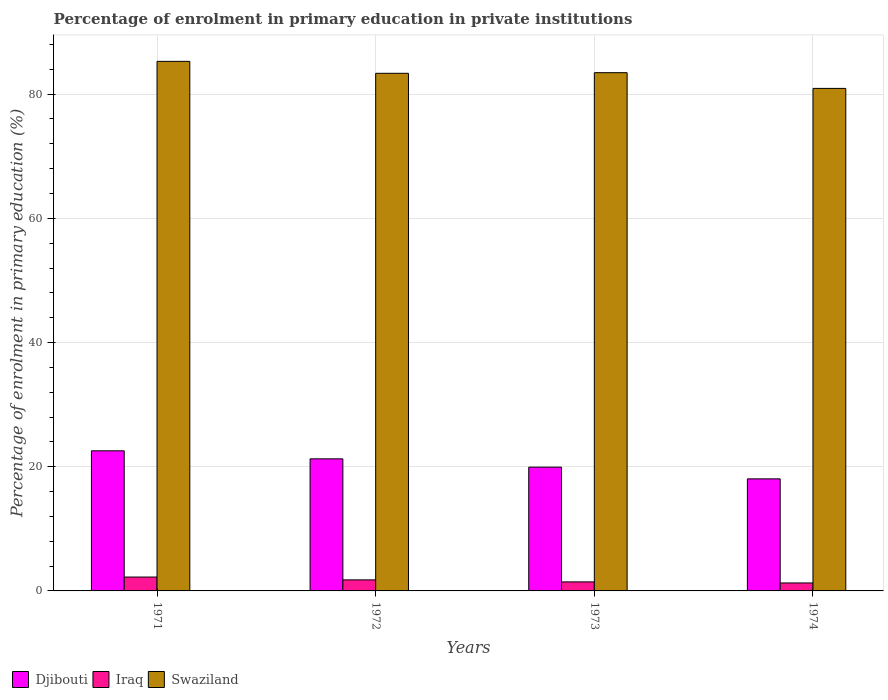How many different coloured bars are there?
Your response must be concise. 3. Are the number of bars per tick equal to the number of legend labels?
Make the answer very short. Yes. How many bars are there on the 3rd tick from the right?
Provide a succinct answer. 3. What is the label of the 2nd group of bars from the left?
Make the answer very short. 1972. What is the percentage of enrolment in primary education in Swaziland in 1972?
Give a very brief answer. 83.35. Across all years, what is the maximum percentage of enrolment in primary education in Djibouti?
Your answer should be very brief. 22.56. Across all years, what is the minimum percentage of enrolment in primary education in Djibouti?
Ensure brevity in your answer.  18.04. In which year was the percentage of enrolment in primary education in Djibouti minimum?
Your answer should be very brief. 1974. What is the total percentage of enrolment in primary education in Djibouti in the graph?
Offer a very short reply. 81.81. What is the difference between the percentage of enrolment in primary education in Djibouti in 1972 and that in 1974?
Give a very brief answer. 3.23. What is the difference between the percentage of enrolment in primary education in Iraq in 1973 and the percentage of enrolment in primary education in Swaziland in 1971?
Your answer should be very brief. -83.82. What is the average percentage of enrolment in primary education in Iraq per year?
Make the answer very short. 1.69. In the year 1974, what is the difference between the percentage of enrolment in primary education in Swaziland and percentage of enrolment in primary education in Iraq?
Your response must be concise. 79.64. In how many years, is the percentage of enrolment in primary education in Djibouti greater than 64 %?
Provide a short and direct response. 0. What is the ratio of the percentage of enrolment in primary education in Iraq in 1971 to that in 1972?
Make the answer very short. 1.26. What is the difference between the highest and the second highest percentage of enrolment in primary education in Swaziland?
Provide a short and direct response. 1.82. What is the difference between the highest and the lowest percentage of enrolment in primary education in Swaziland?
Offer a terse response. 4.36. What does the 3rd bar from the left in 1974 represents?
Offer a terse response. Swaziland. What does the 3rd bar from the right in 1972 represents?
Your response must be concise. Djibouti. Is it the case that in every year, the sum of the percentage of enrolment in primary education in Iraq and percentage of enrolment in primary education in Swaziland is greater than the percentage of enrolment in primary education in Djibouti?
Offer a very short reply. Yes. How many bars are there?
Offer a terse response. 12. Are all the bars in the graph horizontal?
Your response must be concise. No. What is the difference between two consecutive major ticks on the Y-axis?
Give a very brief answer. 20. Does the graph contain grids?
Offer a terse response. Yes. Where does the legend appear in the graph?
Offer a very short reply. Bottom left. How many legend labels are there?
Your response must be concise. 3. What is the title of the graph?
Provide a short and direct response. Percentage of enrolment in primary education in private institutions. What is the label or title of the X-axis?
Offer a terse response. Years. What is the label or title of the Y-axis?
Keep it short and to the point. Percentage of enrolment in primary education (%). What is the Percentage of enrolment in primary education (%) of Djibouti in 1971?
Provide a succinct answer. 22.56. What is the Percentage of enrolment in primary education (%) of Iraq in 1971?
Your answer should be compact. 2.23. What is the Percentage of enrolment in primary education (%) in Swaziland in 1971?
Provide a succinct answer. 85.28. What is the Percentage of enrolment in primary education (%) in Djibouti in 1972?
Give a very brief answer. 21.27. What is the Percentage of enrolment in primary education (%) of Iraq in 1972?
Make the answer very short. 1.78. What is the Percentage of enrolment in primary education (%) in Swaziland in 1972?
Offer a very short reply. 83.35. What is the Percentage of enrolment in primary education (%) of Djibouti in 1973?
Ensure brevity in your answer.  19.93. What is the Percentage of enrolment in primary education (%) in Iraq in 1973?
Make the answer very short. 1.45. What is the Percentage of enrolment in primary education (%) of Swaziland in 1973?
Your answer should be very brief. 83.45. What is the Percentage of enrolment in primary education (%) in Djibouti in 1974?
Give a very brief answer. 18.04. What is the Percentage of enrolment in primary education (%) of Iraq in 1974?
Make the answer very short. 1.28. What is the Percentage of enrolment in primary education (%) of Swaziland in 1974?
Keep it short and to the point. 80.92. Across all years, what is the maximum Percentage of enrolment in primary education (%) of Djibouti?
Provide a succinct answer. 22.56. Across all years, what is the maximum Percentage of enrolment in primary education (%) in Iraq?
Ensure brevity in your answer.  2.23. Across all years, what is the maximum Percentage of enrolment in primary education (%) of Swaziland?
Offer a very short reply. 85.28. Across all years, what is the minimum Percentage of enrolment in primary education (%) of Djibouti?
Provide a short and direct response. 18.04. Across all years, what is the minimum Percentage of enrolment in primary education (%) in Iraq?
Make the answer very short. 1.28. Across all years, what is the minimum Percentage of enrolment in primary education (%) of Swaziland?
Keep it short and to the point. 80.92. What is the total Percentage of enrolment in primary education (%) in Djibouti in the graph?
Provide a succinct answer. 81.81. What is the total Percentage of enrolment in primary education (%) of Iraq in the graph?
Your answer should be very brief. 6.75. What is the total Percentage of enrolment in primary education (%) in Swaziland in the graph?
Ensure brevity in your answer.  333.01. What is the difference between the Percentage of enrolment in primary education (%) in Djibouti in 1971 and that in 1972?
Keep it short and to the point. 1.29. What is the difference between the Percentage of enrolment in primary education (%) in Iraq in 1971 and that in 1972?
Make the answer very short. 0.46. What is the difference between the Percentage of enrolment in primary education (%) in Swaziland in 1971 and that in 1972?
Keep it short and to the point. 1.92. What is the difference between the Percentage of enrolment in primary education (%) of Djibouti in 1971 and that in 1973?
Keep it short and to the point. 2.63. What is the difference between the Percentage of enrolment in primary education (%) of Iraq in 1971 and that in 1973?
Ensure brevity in your answer.  0.78. What is the difference between the Percentage of enrolment in primary education (%) in Swaziland in 1971 and that in 1973?
Give a very brief answer. 1.82. What is the difference between the Percentage of enrolment in primary education (%) of Djibouti in 1971 and that in 1974?
Offer a very short reply. 4.52. What is the difference between the Percentage of enrolment in primary education (%) of Iraq in 1971 and that in 1974?
Give a very brief answer. 0.95. What is the difference between the Percentage of enrolment in primary education (%) in Swaziland in 1971 and that in 1974?
Make the answer very short. 4.36. What is the difference between the Percentage of enrolment in primary education (%) in Djibouti in 1972 and that in 1973?
Your response must be concise. 1.34. What is the difference between the Percentage of enrolment in primary education (%) in Iraq in 1972 and that in 1973?
Your answer should be compact. 0.32. What is the difference between the Percentage of enrolment in primary education (%) of Swaziland in 1972 and that in 1973?
Your answer should be compact. -0.1. What is the difference between the Percentage of enrolment in primary education (%) of Djibouti in 1972 and that in 1974?
Offer a very short reply. 3.23. What is the difference between the Percentage of enrolment in primary education (%) in Iraq in 1972 and that in 1974?
Offer a terse response. 0.5. What is the difference between the Percentage of enrolment in primary education (%) in Swaziland in 1972 and that in 1974?
Make the answer very short. 2.43. What is the difference between the Percentage of enrolment in primary education (%) in Djibouti in 1973 and that in 1974?
Ensure brevity in your answer.  1.89. What is the difference between the Percentage of enrolment in primary education (%) in Iraq in 1973 and that in 1974?
Ensure brevity in your answer.  0.17. What is the difference between the Percentage of enrolment in primary education (%) of Swaziland in 1973 and that in 1974?
Make the answer very short. 2.53. What is the difference between the Percentage of enrolment in primary education (%) in Djibouti in 1971 and the Percentage of enrolment in primary education (%) in Iraq in 1972?
Keep it short and to the point. 20.79. What is the difference between the Percentage of enrolment in primary education (%) in Djibouti in 1971 and the Percentage of enrolment in primary education (%) in Swaziland in 1972?
Your answer should be compact. -60.79. What is the difference between the Percentage of enrolment in primary education (%) of Iraq in 1971 and the Percentage of enrolment in primary education (%) of Swaziland in 1972?
Make the answer very short. -81.12. What is the difference between the Percentage of enrolment in primary education (%) in Djibouti in 1971 and the Percentage of enrolment in primary education (%) in Iraq in 1973?
Make the answer very short. 21.11. What is the difference between the Percentage of enrolment in primary education (%) of Djibouti in 1971 and the Percentage of enrolment in primary education (%) of Swaziland in 1973?
Give a very brief answer. -60.89. What is the difference between the Percentage of enrolment in primary education (%) of Iraq in 1971 and the Percentage of enrolment in primary education (%) of Swaziland in 1973?
Your response must be concise. -81.22. What is the difference between the Percentage of enrolment in primary education (%) of Djibouti in 1971 and the Percentage of enrolment in primary education (%) of Iraq in 1974?
Offer a terse response. 21.28. What is the difference between the Percentage of enrolment in primary education (%) of Djibouti in 1971 and the Percentage of enrolment in primary education (%) of Swaziland in 1974?
Your answer should be compact. -58.36. What is the difference between the Percentage of enrolment in primary education (%) of Iraq in 1971 and the Percentage of enrolment in primary education (%) of Swaziland in 1974?
Make the answer very short. -78.69. What is the difference between the Percentage of enrolment in primary education (%) of Djibouti in 1972 and the Percentage of enrolment in primary education (%) of Iraq in 1973?
Offer a terse response. 19.81. What is the difference between the Percentage of enrolment in primary education (%) of Djibouti in 1972 and the Percentage of enrolment in primary education (%) of Swaziland in 1973?
Your answer should be very brief. -62.18. What is the difference between the Percentage of enrolment in primary education (%) of Iraq in 1972 and the Percentage of enrolment in primary education (%) of Swaziland in 1973?
Offer a very short reply. -81.67. What is the difference between the Percentage of enrolment in primary education (%) in Djibouti in 1972 and the Percentage of enrolment in primary education (%) in Iraq in 1974?
Give a very brief answer. 19.99. What is the difference between the Percentage of enrolment in primary education (%) in Djibouti in 1972 and the Percentage of enrolment in primary education (%) in Swaziland in 1974?
Offer a very short reply. -59.65. What is the difference between the Percentage of enrolment in primary education (%) in Iraq in 1972 and the Percentage of enrolment in primary education (%) in Swaziland in 1974?
Offer a terse response. -79.14. What is the difference between the Percentage of enrolment in primary education (%) in Djibouti in 1973 and the Percentage of enrolment in primary education (%) in Iraq in 1974?
Make the answer very short. 18.65. What is the difference between the Percentage of enrolment in primary education (%) in Djibouti in 1973 and the Percentage of enrolment in primary education (%) in Swaziland in 1974?
Your answer should be very brief. -60.99. What is the difference between the Percentage of enrolment in primary education (%) of Iraq in 1973 and the Percentage of enrolment in primary education (%) of Swaziland in 1974?
Your answer should be compact. -79.47. What is the average Percentage of enrolment in primary education (%) in Djibouti per year?
Make the answer very short. 20.45. What is the average Percentage of enrolment in primary education (%) in Iraq per year?
Keep it short and to the point. 1.69. What is the average Percentage of enrolment in primary education (%) of Swaziland per year?
Offer a very short reply. 83.25. In the year 1971, what is the difference between the Percentage of enrolment in primary education (%) in Djibouti and Percentage of enrolment in primary education (%) in Iraq?
Your answer should be compact. 20.33. In the year 1971, what is the difference between the Percentage of enrolment in primary education (%) in Djibouti and Percentage of enrolment in primary education (%) in Swaziland?
Offer a very short reply. -62.71. In the year 1971, what is the difference between the Percentage of enrolment in primary education (%) in Iraq and Percentage of enrolment in primary education (%) in Swaziland?
Offer a terse response. -83.04. In the year 1972, what is the difference between the Percentage of enrolment in primary education (%) of Djibouti and Percentage of enrolment in primary education (%) of Iraq?
Your answer should be compact. 19.49. In the year 1972, what is the difference between the Percentage of enrolment in primary education (%) of Djibouti and Percentage of enrolment in primary education (%) of Swaziland?
Keep it short and to the point. -62.09. In the year 1972, what is the difference between the Percentage of enrolment in primary education (%) in Iraq and Percentage of enrolment in primary education (%) in Swaziland?
Ensure brevity in your answer.  -81.58. In the year 1973, what is the difference between the Percentage of enrolment in primary education (%) of Djibouti and Percentage of enrolment in primary education (%) of Iraq?
Make the answer very short. 18.48. In the year 1973, what is the difference between the Percentage of enrolment in primary education (%) of Djibouti and Percentage of enrolment in primary education (%) of Swaziland?
Make the answer very short. -63.52. In the year 1973, what is the difference between the Percentage of enrolment in primary education (%) of Iraq and Percentage of enrolment in primary education (%) of Swaziland?
Make the answer very short. -82. In the year 1974, what is the difference between the Percentage of enrolment in primary education (%) in Djibouti and Percentage of enrolment in primary education (%) in Iraq?
Give a very brief answer. 16.76. In the year 1974, what is the difference between the Percentage of enrolment in primary education (%) in Djibouti and Percentage of enrolment in primary education (%) in Swaziland?
Provide a short and direct response. -62.88. In the year 1974, what is the difference between the Percentage of enrolment in primary education (%) of Iraq and Percentage of enrolment in primary education (%) of Swaziland?
Keep it short and to the point. -79.64. What is the ratio of the Percentage of enrolment in primary education (%) in Djibouti in 1971 to that in 1972?
Your response must be concise. 1.06. What is the ratio of the Percentage of enrolment in primary education (%) of Iraq in 1971 to that in 1972?
Provide a short and direct response. 1.26. What is the ratio of the Percentage of enrolment in primary education (%) of Swaziland in 1971 to that in 1972?
Provide a short and direct response. 1.02. What is the ratio of the Percentage of enrolment in primary education (%) in Djibouti in 1971 to that in 1973?
Your answer should be very brief. 1.13. What is the ratio of the Percentage of enrolment in primary education (%) of Iraq in 1971 to that in 1973?
Your answer should be very brief. 1.54. What is the ratio of the Percentage of enrolment in primary education (%) of Swaziland in 1971 to that in 1973?
Offer a terse response. 1.02. What is the ratio of the Percentage of enrolment in primary education (%) of Djibouti in 1971 to that in 1974?
Provide a short and direct response. 1.25. What is the ratio of the Percentage of enrolment in primary education (%) of Iraq in 1971 to that in 1974?
Offer a very short reply. 1.74. What is the ratio of the Percentage of enrolment in primary education (%) of Swaziland in 1971 to that in 1974?
Your answer should be compact. 1.05. What is the ratio of the Percentage of enrolment in primary education (%) in Djibouti in 1972 to that in 1973?
Your answer should be very brief. 1.07. What is the ratio of the Percentage of enrolment in primary education (%) in Iraq in 1972 to that in 1973?
Keep it short and to the point. 1.22. What is the ratio of the Percentage of enrolment in primary education (%) of Swaziland in 1972 to that in 1973?
Keep it short and to the point. 1. What is the ratio of the Percentage of enrolment in primary education (%) in Djibouti in 1972 to that in 1974?
Your response must be concise. 1.18. What is the ratio of the Percentage of enrolment in primary education (%) in Iraq in 1972 to that in 1974?
Provide a short and direct response. 1.39. What is the ratio of the Percentage of enrolment in primary education (%) in Swaziland in 1972 to that in 1974?
Offer a terse response. 1.03. What is the ratio of the Percentage of enrolment in primary education (%) in Djibouti in 1973 to that in 1974?
Make the answer very short. 1.1. What is the ratio of the Percentage of enrolment in primary education (%) of Iraq in 1973 to that in 1974?
Offer a terse response. 1.14. What is the ratio of the Percentage of enrolment in primary education (%) in Swaziland in 1973 to that in 1974?
Your answer should be compact. 1.03. What is the difference between the highest and the second highest Percentage of enrolment in primary education (%) of Djibouti?
Offer a terse response. 1.29. What is the difference between the highest and the second highest Percentage of enrolment in primary education (%) in Iraq?
Your answer should be compact. 0.46. What is the difference between the highest and the second highest Percentage of enrolment in primary education (%) in Swaziland?
Your response must be concise. 1.82. What is the difference between the highest and the lowest Percentage of enrolment in primary education (%) in Djibouti?
Offer a terse response. 4.52. What is the difference between the highest and the lowest Percentage of enrolment in primary education (%) in Iraq?
Offer a terse response. 0.95. What is the difference between the highest and the lowest Percentage of enrolment in primary education (%) of Swaziland?
Your answer should be very brief. 4.36. 